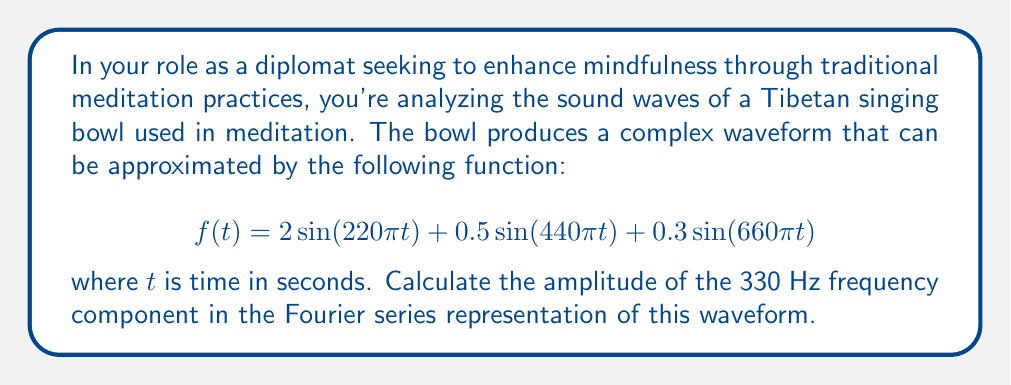Give your solution to this math problem. To solve this problem, we need to follow these steps:

1) First, recognize that the given function is already in the form of a Fourier series, specifically a sum of sine waves with different frequencies and amplitudes.

2) Identify the frequencies in the given function:
   - $220\pi$ rad/s corresponds to 110 Hz
   - $440\pi$ rad/s corresponds to 220 Hz
   - $660\pi$ rad/s corresponds to 330 Hz

3) The general form of a Fourier series is:

   $$f(t) = a_0 + \sum_{n=1}^{\infty} [a_n \cos(n\omega_0 t) + b_n \sin(n\omega_0 t)]$$

   where $a_n$ and $b_n$ are the amplitudes of the cosine and sine components respectively.

4) In our case, we only have sine terms, so we're only concerned with the $b_n$ coefficients.

5) The amplitude of each frequency component is given by the coefficient of its sine term.

6) Looking at the 330 Hz component (corresponding to $660\pi t$), we can see its coefficient is 0.3.

Therefore, the amplitude of the 330 Hz frequency component is 0.3.
Answer: 0.3 